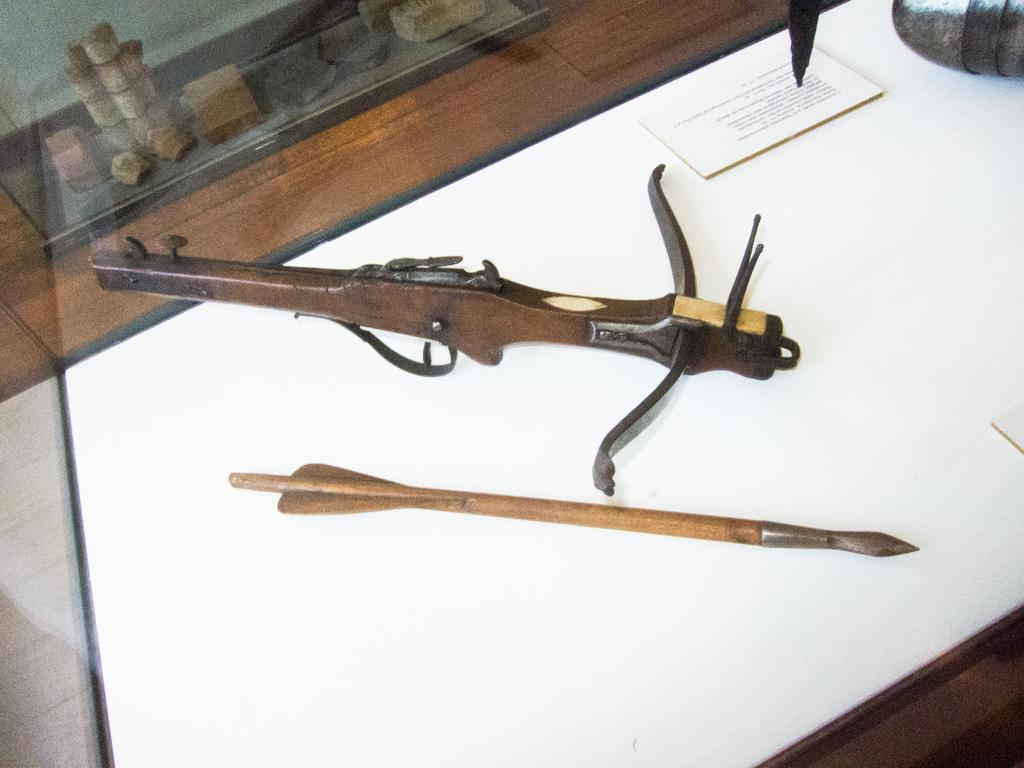What type of weapon is present in the image? There is a rifle in the image. What other object related to projectiles can be seen in the image? There is an arrow in the image. What non-weapon object is present in the image? There is a book in the image. What color is the table in the image? The table is white. What natural material is present in the image? There are stones in the image. What type of door is visible in the image? There is a glass door in the image. How many mittens are on the table in the image? There are no mittens present in the image. What type of precipitation can be seen falling outside the glass door in the image? There is no precipitation visible in the image, and the weather cannot be determined from the provided facts. 